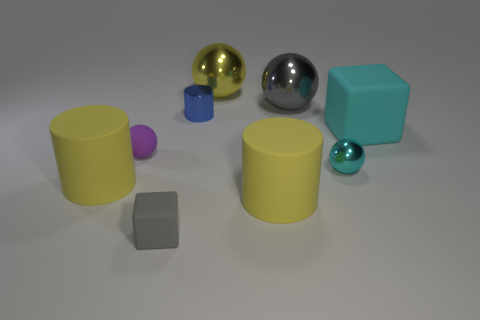What number of cylinders are either small blue things or tiny cyan shiny objects?
Give a very brief answer. 1. What number of big things are both on the left side of the cyan block and in front of the big gray thing?
Offer a very short reply. 2. Does the gray sphere have the same size as the rubber cylinder that is left of the matte sphere?
Your answer should be compact. Yes. There is a big object to the right of the metal sphere that is in front of the large cyan rubber block; are there any big cylinders that are behind it?
Make the answer very short. No. The cyan object in front of the big object that is right of the cyan shiny thing is made of what material?
Your answer should be compact. Metal. The tiny object that is to the left of the small blue metallic cylinder and behind the gray rubber cube is made of what material?
Provide a short and direct response. Rubber. Is there a yellow thing that has the same shape as the small gray thing?
Provide a short and direct response. No. Is there a yellow shiny ball that is in front of the metallic object in front of the matte ball?
Offer a terse response. No. What number of spheres are the same material as the cyan cube?
Your answer should be very brief. 1. Is there a red block?
Keep it short and to the point. No. 